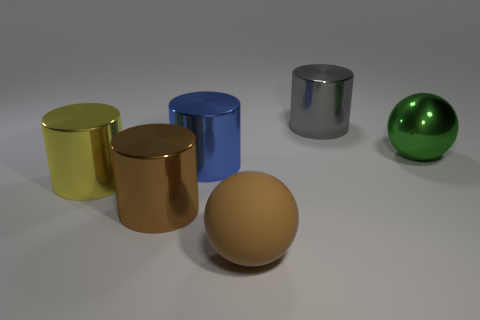Subtract all large brown metal cylinders. How many cylinders are left? 3 Subtract all brown cylinders. How many cylinders are left? 3 Subtract all red cylinders. Subtract all green blocks. How many cylinders are left? 4 Add 4 tiny cyan cylinders. How many objects exist? 10 Subtract all cylinders. How many objects are left? 2 Add 1 large brown shiny things. How many large brown shiny things are left? 2 Add 6 small green cylinders. How many small green cylinders exist? 6 Subtract 0 blue balls. How many objects are left? 6 Subtract all brown shiny cylinders. Subtract all large yellow metallic cylinders. How many objects are left? 4 